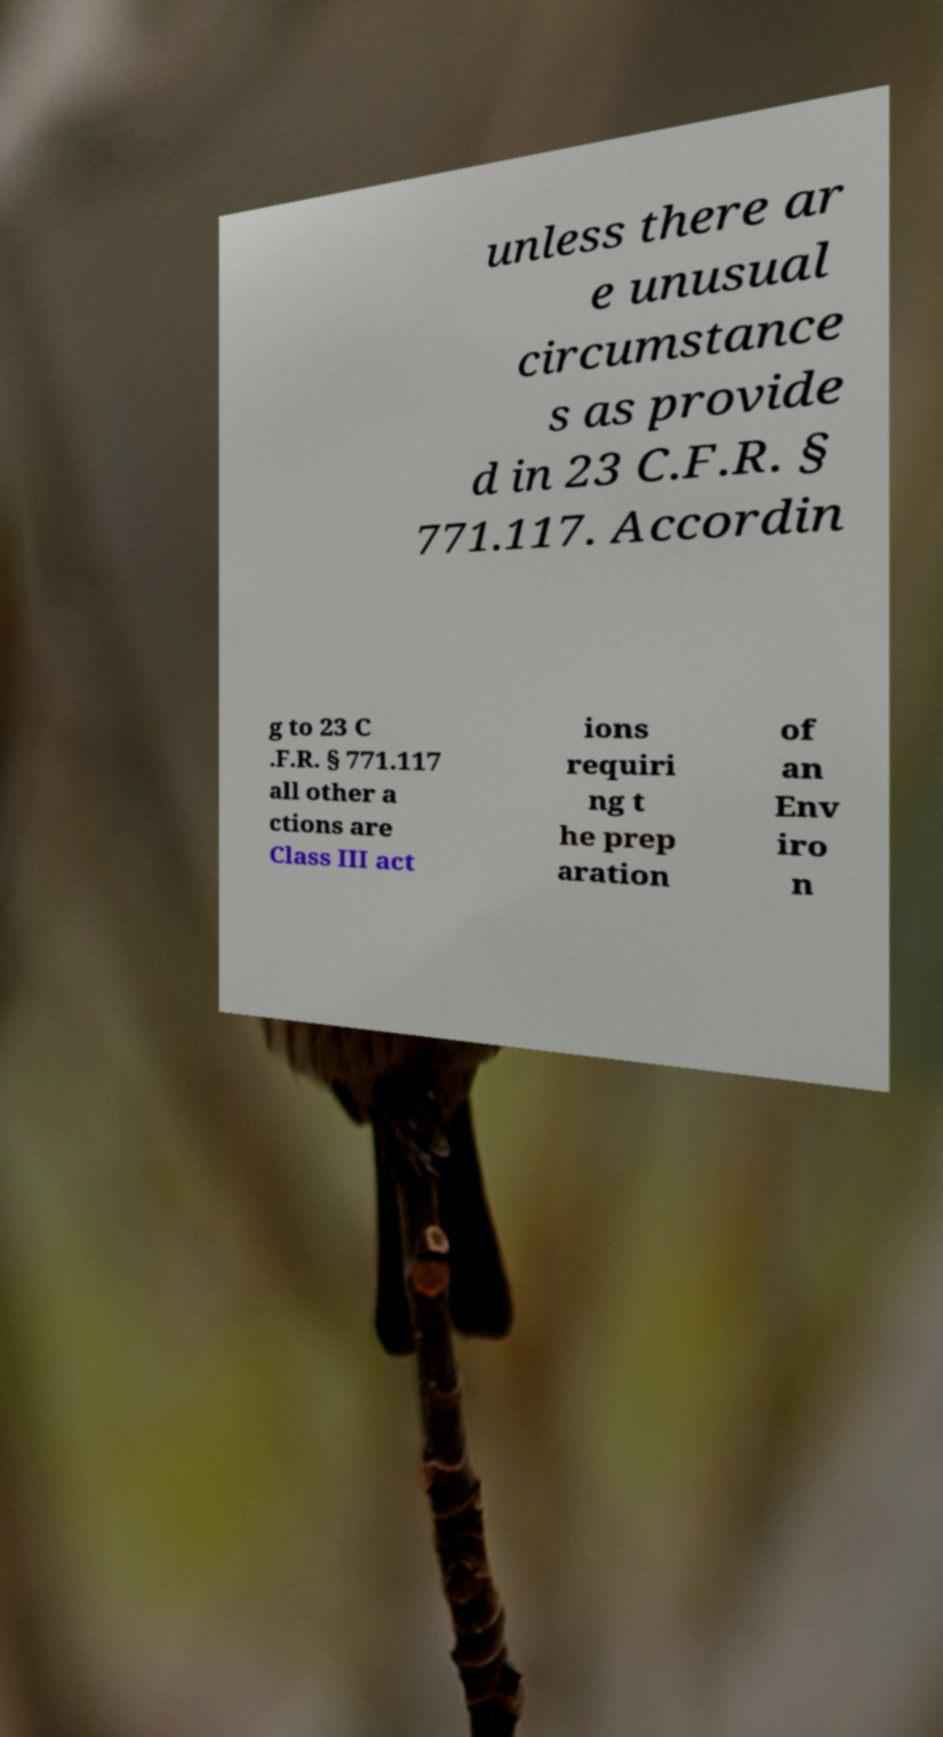Can you accurately transcribe the text from the provided image for me? unless there ar e unusual circumstance s as provide d in 23 C.F.R. § 771.117. Accordin g to 23 C .F.R. § 771.117 all other a ctions are Class III act ions requiri ng t he prep aration of an Env iro n 